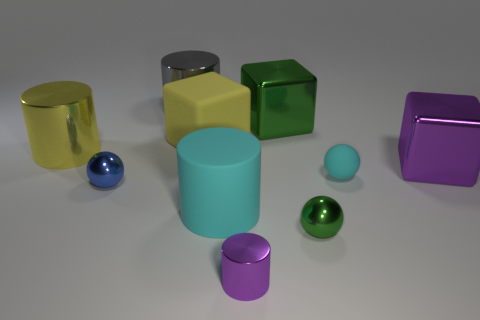Subtract all big shiny blocks. How many blocks are left? 1 Subtract 1 balls. How many balls are left? 2 Subtract all purple cylinders. How many cylinders are left? 3 Subtract all cylinders. How many objects are left? 6 Subtract all tiny purple metal things. Subtract all cyan matte balls. How many objects are left? 8 Add 6 purple objects. How many purple objects are left? 8 Add 1 gray metal objects. How many gray metal objects exist? 2 Subtract 1 green balls. How many objects are left? 9 Subtract all yellow cylinders. Subtract all cyan blocks. How many cylinders are left? 3 Subtract all red cubes. How many red balls are left? 0 